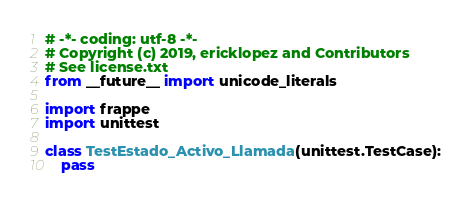Convert code to text. <code><loc_0><loc_0><loc_500><loc_500><_Python_># -*- coding: utf-8 -*-
# Copyright (c) 2019, ericklopez and Contributors
# See license.txt
from __future__ import unicode_literals

import frappe
import unittest

class TestEstado_Activo_Llamada(unittest.TestCase):
	pass
</code> 